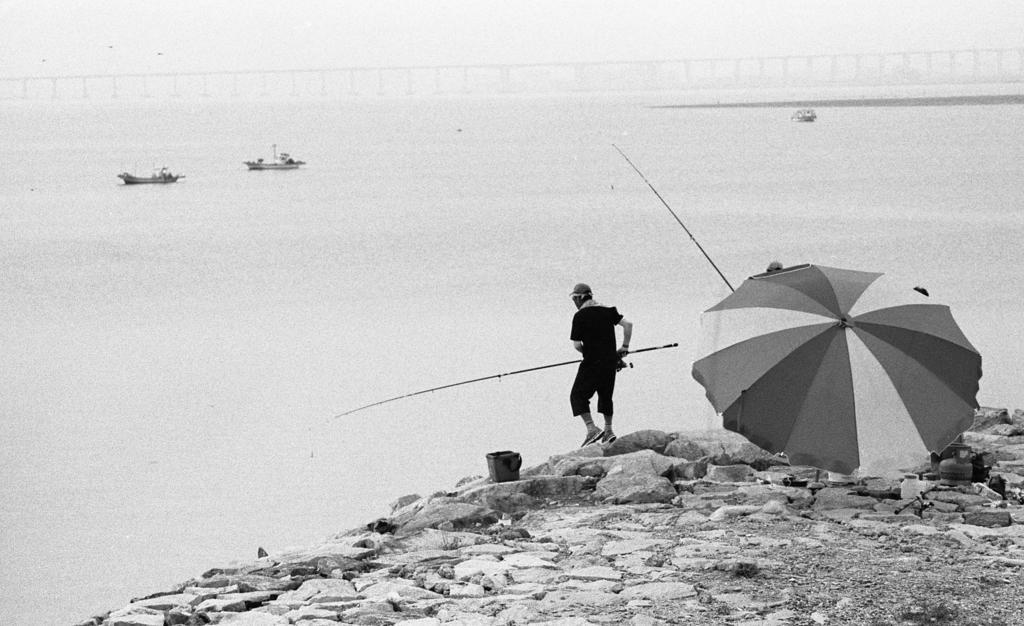How would you summarize this image in a sentence or two? In this image, at the right side there is an umbrella and there is a man holding a stick, we can see water and there are some boats on the water. 